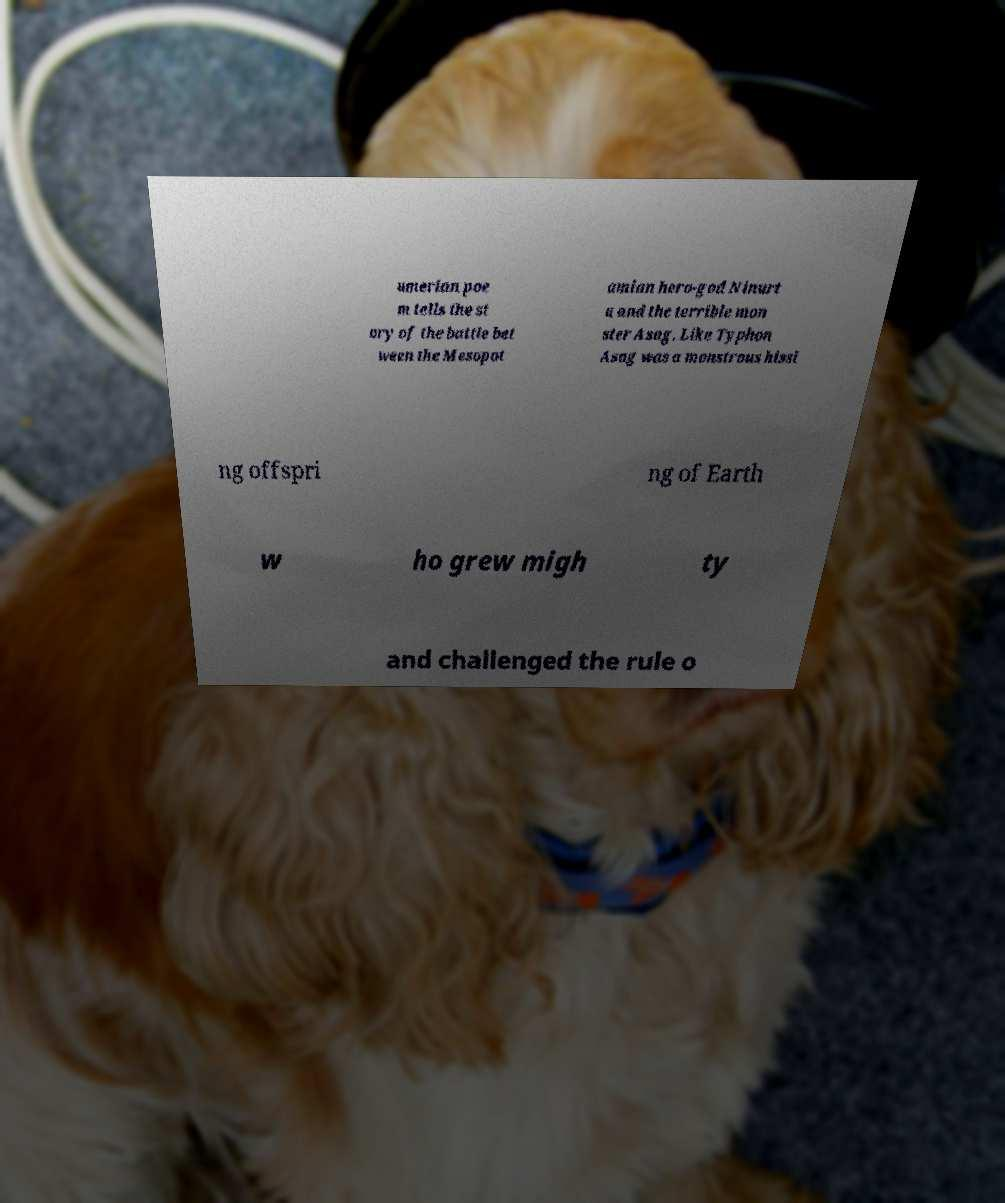Please read and relay the text visible in this image. What does it say? umerian poe m tells the st ory of the battle bet ween the Mesopot amian hero-god Ninurt a and the terrible mon ster Asag. Like Typhon Asag was a monstrous hissi ng offspri ng of Earth w ho grew migh ty and challenged the rule o 